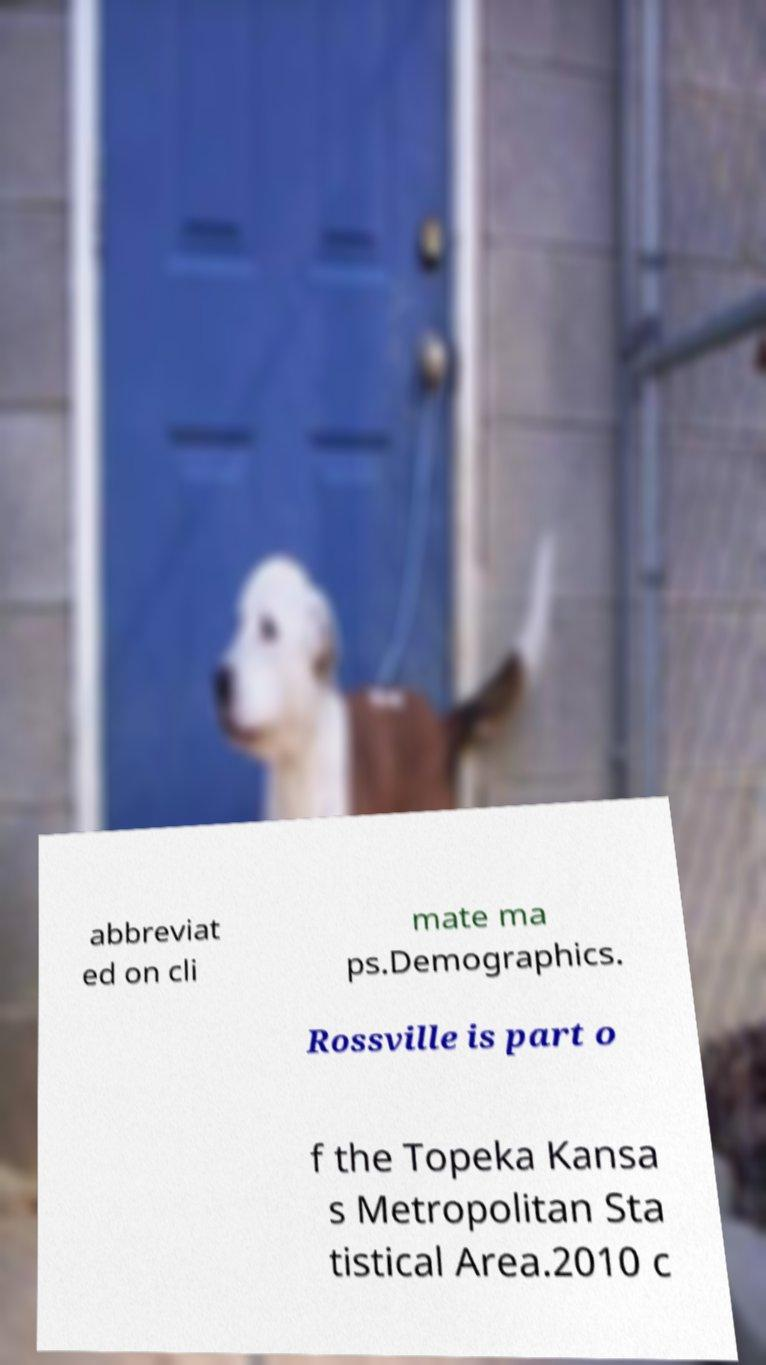Could you assist in decoding the text presented in this image and type it out clearly? abbreviat ed on cli mate ma ps.Demographics. Rossville is part o f the Topeka Kansa s Metropolitan Sta tistical Area.2010 c 